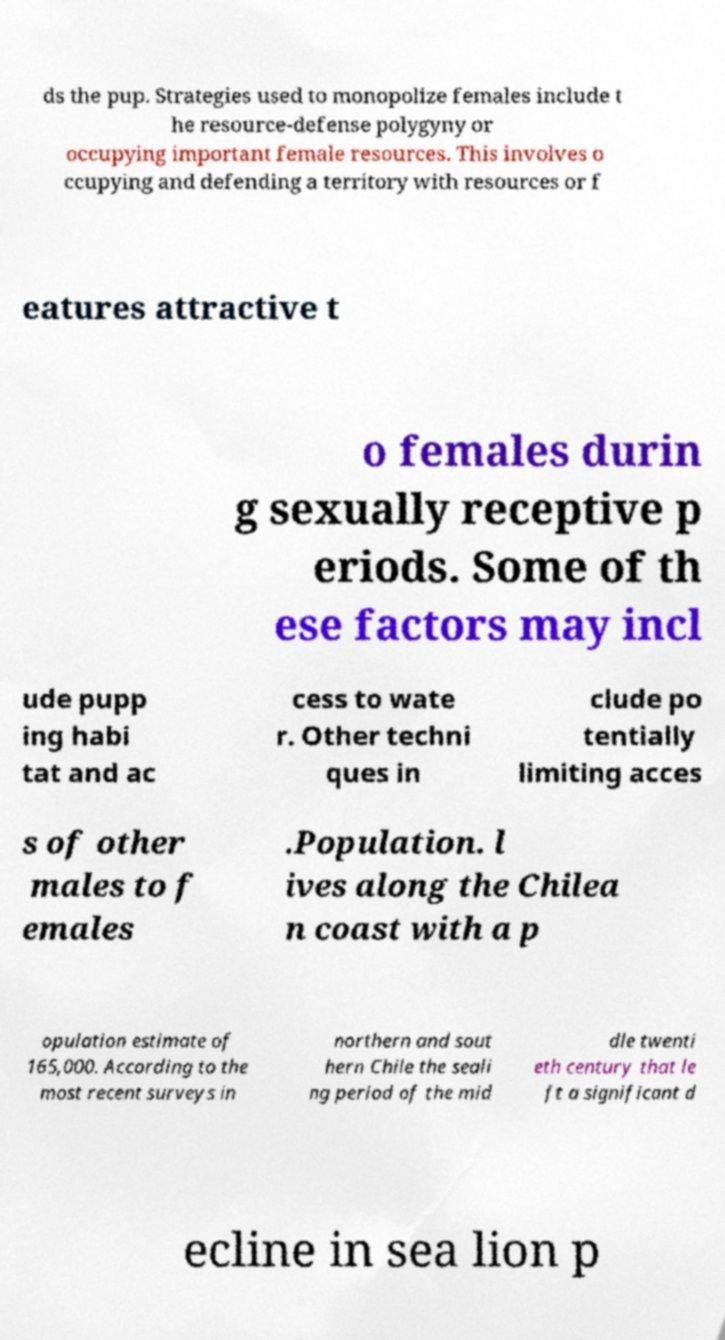Please read and relay the text visible in this image. What does it say? ds the pup. Strategies used to monopolize females include t he resource-defense polygyny or occupying important female resources. This involves o ccupying and defending a territory with resources or f eatures attractive t o females durin g sexually receptive p eriods. Some of th ese factors may incl ude pupp ing habi tat and ac cess to wate r. Other techni ques in clude po tentially limiting acces s of other males to f emales .Population. l ives along the Chilea n coast with a p opulation estimate of 165,000. According to the most recent surveys in northern and sout hern Chile the seali ng period of the mid dle twenti eth century that le ft a significant d ecline in sea lion p 